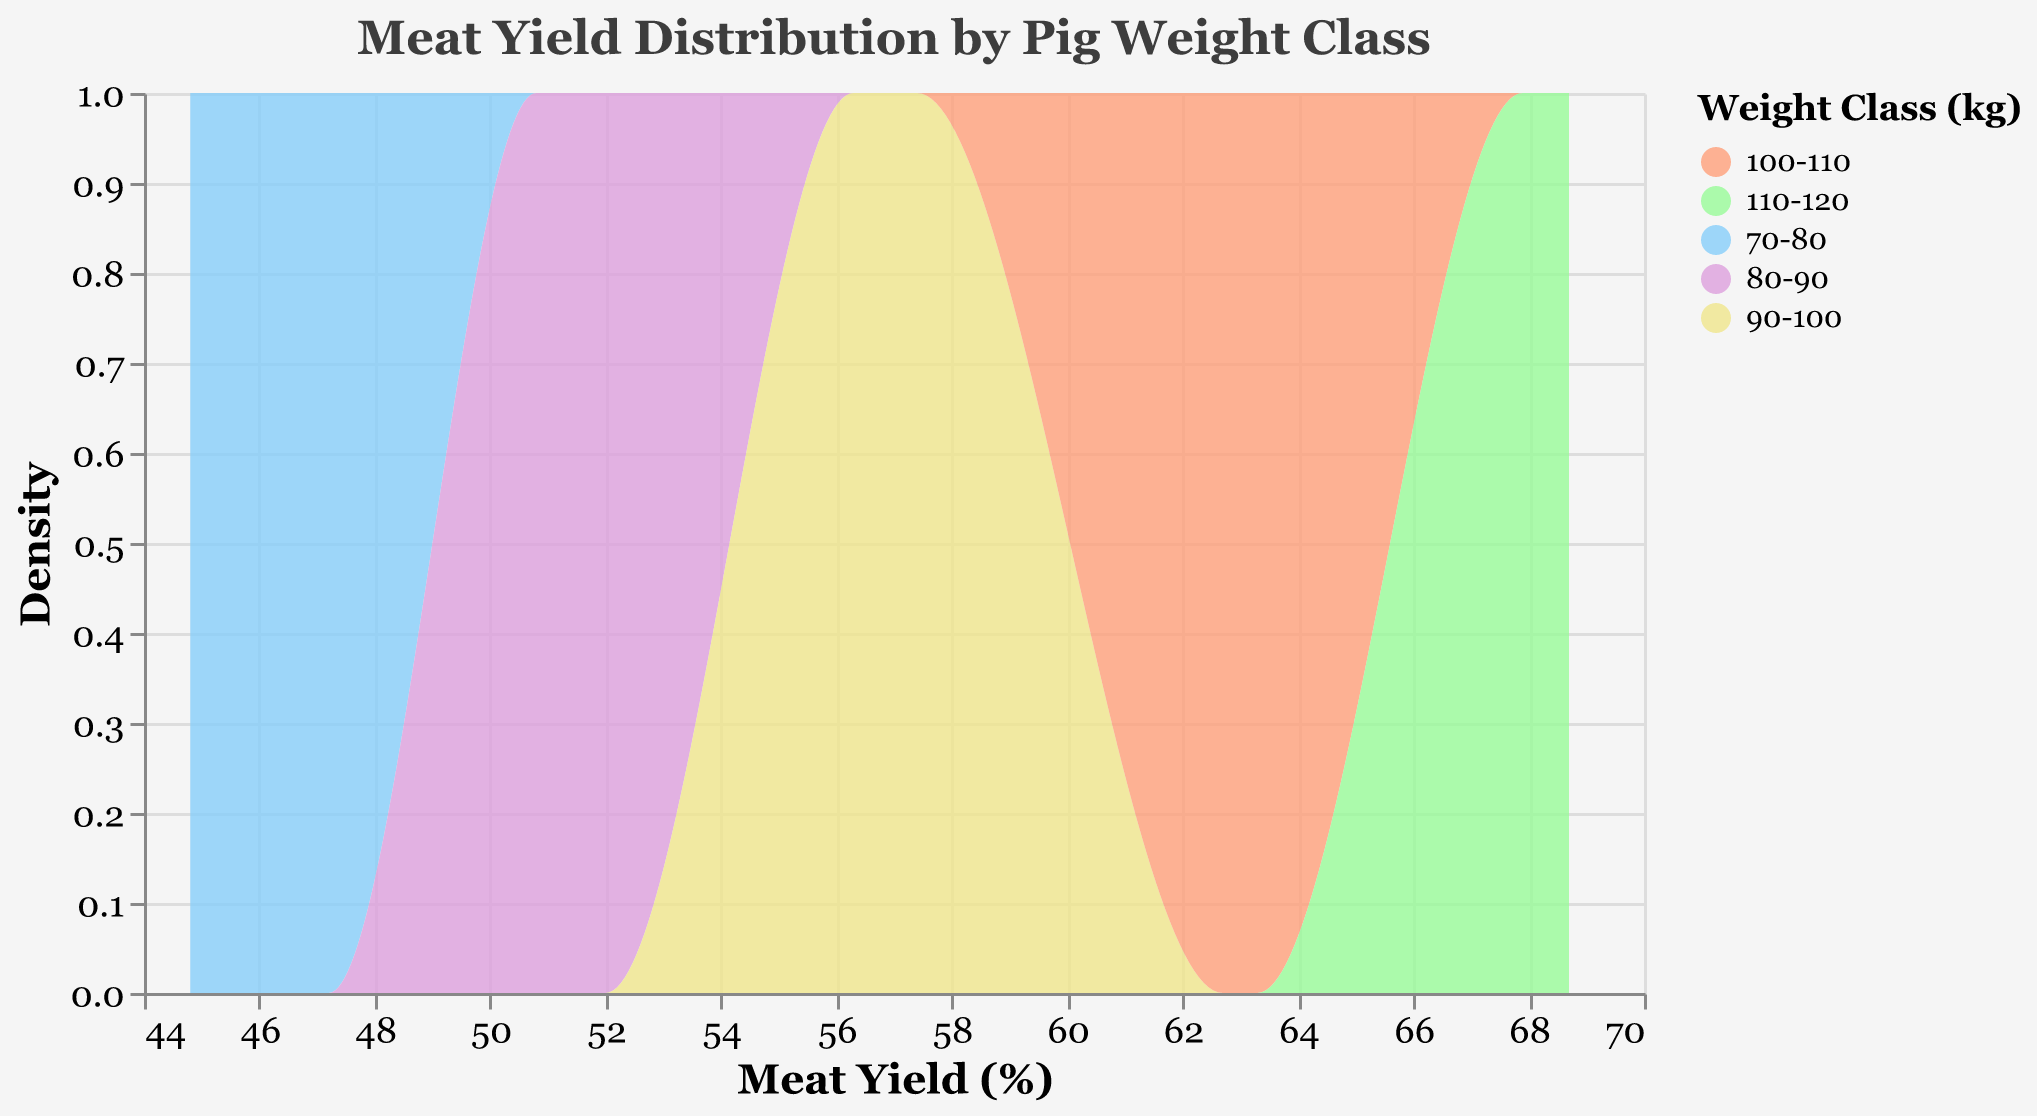what is the title of the plot? The title is displayed at the top of the plot in a larger font size. It reads "Meat Yield Distribution by Pig Weight Class".
Answer: Meat Yield Distribution by Pig Weight Class what does the x-axis represent? The x-axis has the title "Meat Yield (%)" and shows the range of meat yields in percentage. The data points in the plot are distributed along this axis based on their meat yields.
Answer: Meat Yield (%) which weight class has the highest density peak? The highest density peak is represented by the highest point on the y-axis for each color. By visually inspecting the plot, you can identify that the weight class with the highest density peak has darker shade of greenish-blue.
Answer: 110-120 between which two weight classes is the meat yield difference the smallest? To find this, examine the central tendency (peak) of the density curves for each weight class. The two weight classes that have their peak values closest to each other likely have the smallest difference in meat yield. Visually, the difference between 100-110 kg and 110-120 kg classes appears the smallest.
Answer: 100-110 and 110-120 how many unique weight classes are represented in the plot? The plot legend lists the categories represented by different colors in the plot. By counting these categories, you can find the number of unique weight classes.
Answer: 5 which weight classes have overlapping meat yield distributions? By inspecting the plot, one can see the areas where the density curves of different colors overlap. The weight classes of 70-80 and 80-90 kg as well as 90-100 and 100-110 kg overlap in their meat yield distributions.
Answer: 70-80 and 80-90; 90-100 and 100-110 what is the range of the meat yield percentage in the plot? The x-axis represents the meat yield percentage and the range is defined by the minimum and maximum values shown. By looking at the plot, the meat yield range falls between approximately 44% and 69%.
Answer: 44% to 69% which weight class has the narrowest range of meat yield distribution? The narrowness of the distribution can be identified by looking at the width of the density peak. The weight class 100-110 kg shows the narrowest distribution range visually.
Answer: 100-110 do larger weight classes tend to have higher meat yields? By observing the central peak positions of each weight class' density curves, you can infer that larger weight classes (higher weight ranges) tend to have higher meat yield percentages. Most heavier classes show their density peaks at greater meat yield percentages.
Answer: Yes which weight class shows the widest distribution range in meat yield? The width of the density curve indicates the range of values. The 110-120 kg weight class has the broadest distribution range, from the leftmost to the rightmost points of its density curve.
Answer: 110-120 